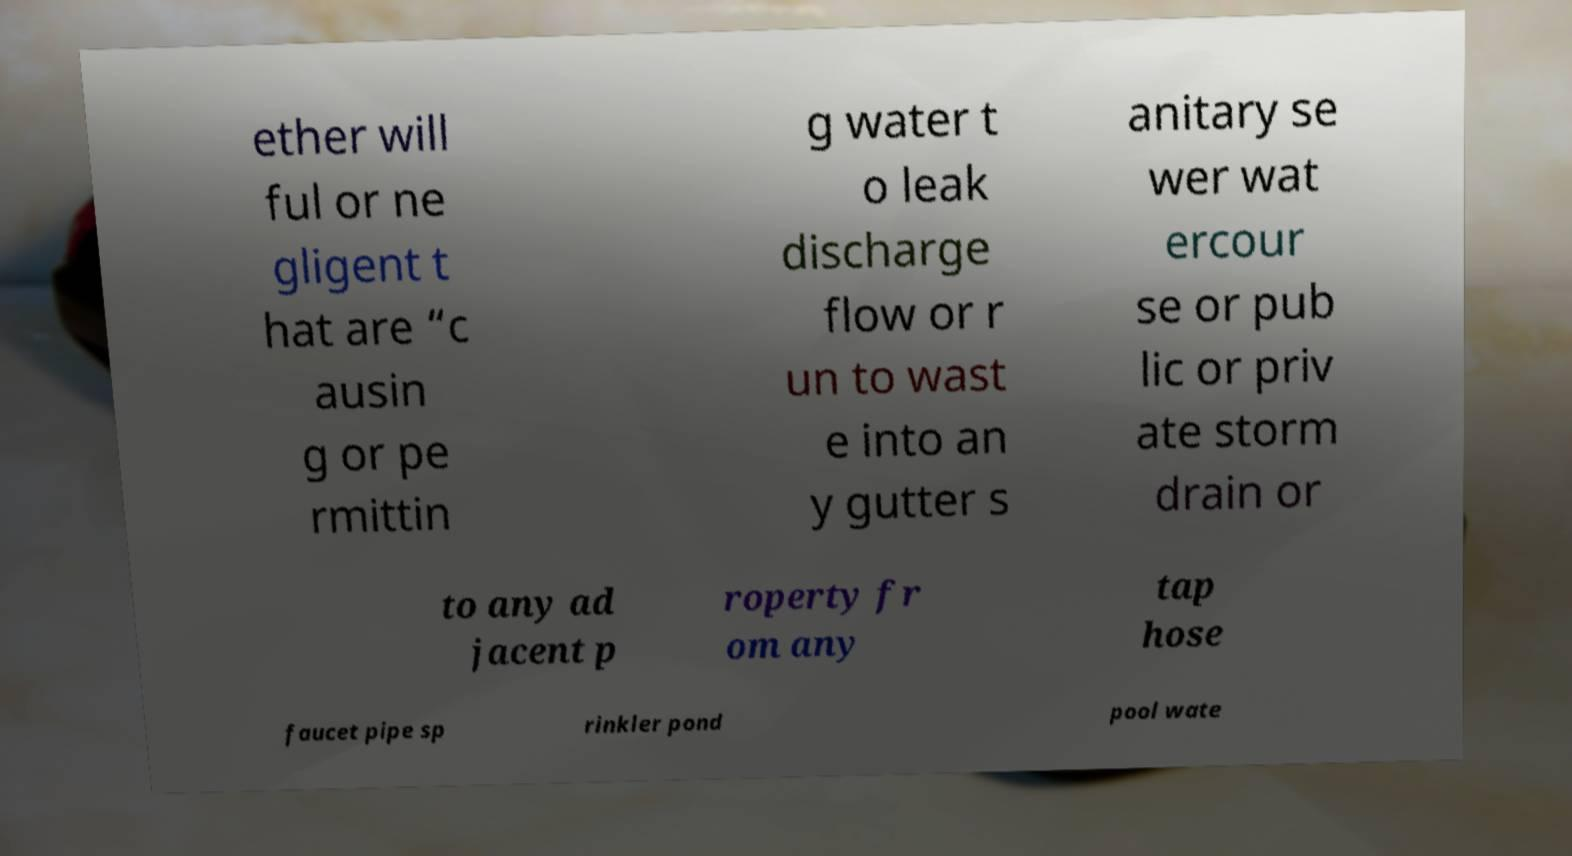For documentation purposes, I need the text within this image transcribed. Could you provide that? ether will ful or ne gligent t hat are “c ausin g or pe rmittin g water t o leak discharge flow or r un to wast e into an y gutter s anitary se wer wat ercour se or pub lic or priv ate storm drain or to any ad jacent p roperty fr om any tap hose faucet pipe sp rinkler pond pool wate 